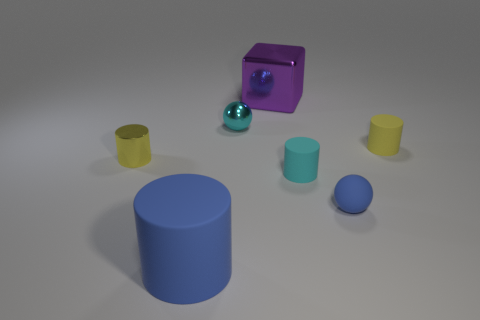Subtract all big cylinders. How many cylinders are left? 3 Subtract all green spheres. How many yellow cylinders are left? 2 Add 2 big things. How many objects exist? 9 Subtract 1 cylinders. How many cylinders are left? 3 Subtract all cyan cylinders. How many cylinders are left? 3 Subtract all cylinders. How many objects are left? 3 Subtract all cyan cylinders. Subtract all brown spheres. How many cylinders are left? 3 Add 2 purple things. How many purple things exist? 3 Subtract 0 gray cubes. How many objects are left? 7 Subtract all large metal cylinders. Subtract all tiny metal cylinders. How many objects are left? 6 